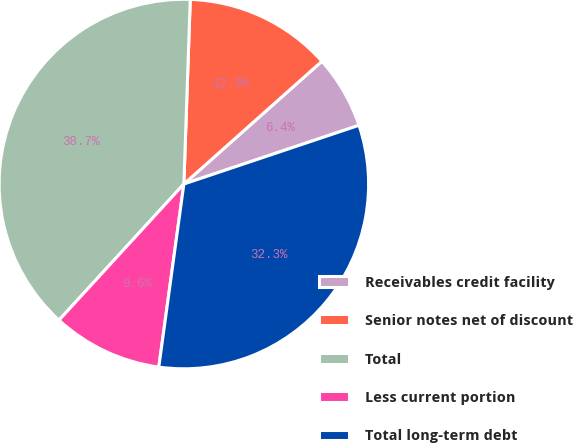Convert chart to OTSL. <chart><loc_0><loc_0><loc_500><loc_500><pie_chart><fcel>Receivables credit facility<fcel>Senior notes net of discount<fcel>Total<fcel>Less current portion<fcel>Total long-term debt<nl><fcel>6.42%<fcel>12.88%<fcel>38.74%<fcel>9.65%<fcel>32.32%<nl></chart> 